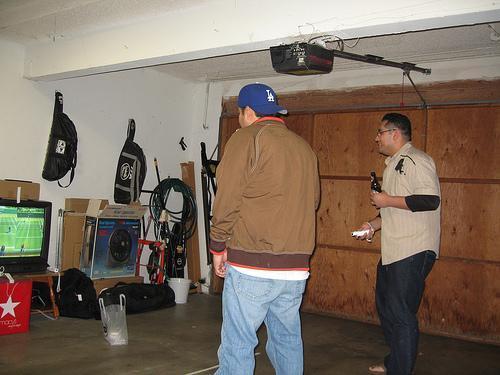How many people are wearing a baseball cap?
Give a very brief answer. 1. 